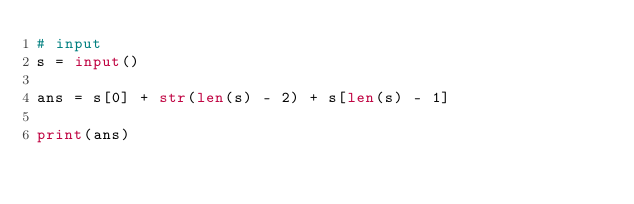<code> <loc_0><loc_0><loc_500><loc_500><_Python_># input
s = input()

ans = s[0] + str(len(s) - 2) + s[len(s) - 1]

print(ans)</code> 